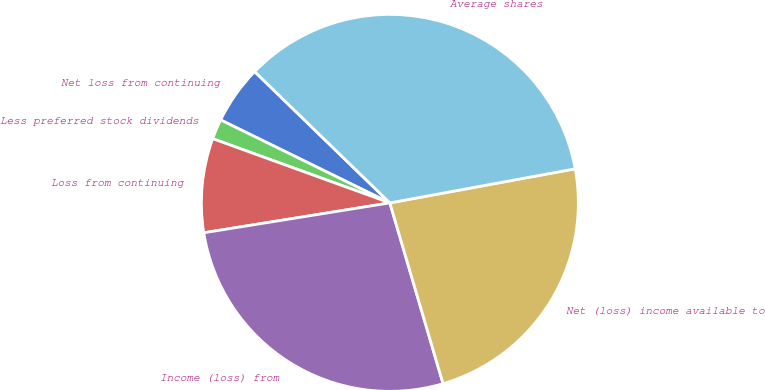<chart> <loc_0><loc_0><loc_500><loc_500><pie_chart><fcel>Net loss from continuing<fcel>Less preferred stock dividends<fcel>Loss from continuing<fcel>Income (loss) from<fcel>Net (loss) income available to<fcel>Average shares<nl><fcel>5.01%<fcel>1.72%<fcel>8.07%<fcel>27.02%<fcel>23.34%<fcel>34.84%<nl></chart> 